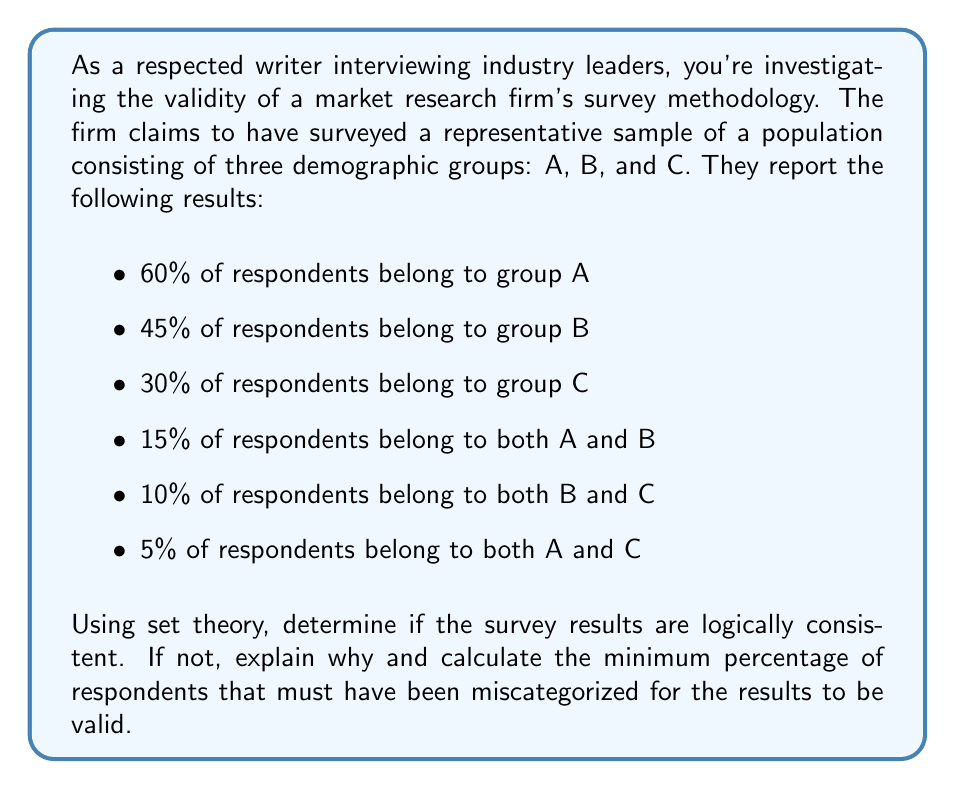What is the answer to this math problem? To evaluate the validity of the survey results using set theory, we need to consider the principle of inclusion-exclusion and the concept of a universal set.

Let's define our sets:
$A$: respondents belonging to group A
$B$: respondents belonging to group B
$C$: respondents belonging to group C
$U$: the universal set (all respondents)

Given:
$P(A) = 0.60$
$P(B) = 0.45$
$P(C) = 0.30$
$P(A \cap B) = 0.15$
$P(B \cap C) = 0.10$
$P(A \cap C) = 0.05$

Step 1: Calculate $P(A \cup B \cup C)$ using the inclusion-exclusion principle:

$P(A \cup B \cup C) = P(A) + P(B) + P(C) - P(A \cap B) - P(B \cap C) - P(A \cap C) + P(A \cap B \cap C)$

Step 2: Substitute the known values:

$P(A \cup B \cup C) = 0.60 + 0.45 + 0.30 - 0.15 - 0.10 - 0.05 + P(A \cap B \cap C)$

Step 3: Simplify:

$P(A \cup B \cup C) = 1.05 + P(A \cap B \cap C)$

Step 4: Evaluate logical consistency:

For the results to be logically consistent, $P(A \cup B \cup C)$ must be less than or equal to 1, as it represents the probability of a respondent belonging to at least one of the groups.

However, we can see that even without considering $P(A \cap B \cap C)$, which is non-negative, $P(A \cup B \cup C)$ is already greater than 1.

Step 5: Calculate the minimum percentage of miscategorized respondents:

The minimum miscategorization occurs when $P(A \cap B \cap C) = 0$. In this case:

$P(A \cup B \cup C) = 1.05$

The excess probability is 0.05, or 5%.

Therefore, at least 5% of respondents must have been miscategorized for the results to be valid.
Answer: The survey results are not logically consistent. A minimum of 5% of respondents must have been miscategorized for the results to be valid. 